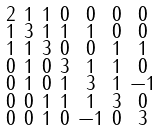<formula> <loc_0><loc_0><loc_500><loc_500>\begin{smallmatrix} 2 & 1 & 1 & 0 & 0 & 0 & 0 \\ 1 & 3 & 1 & 1 & 1 & 0 & 0 \\ 1 & 1 & 3 & 0 & 0 & 1 & 1 \\ 0 & 1 & 0 & 3 & 1 & 1 & 0 \\ 0 & 1 & 0 & 1 & 3 & 1 & - 1 \\ 0 & 0 & 1 & 1 & 1 & 3 & 0 \\ 0 & 0 & 1 & 0 & - 1 & 0 & 3 \end{smallmatrix}</formula> 